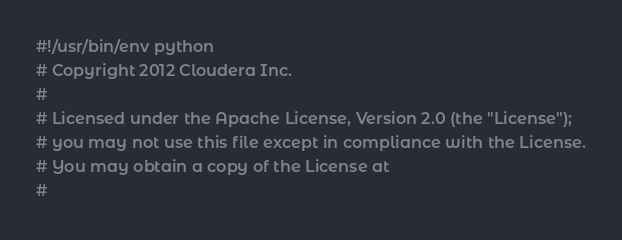<code> <loc_0><loc_0><loc_500><loc_500><_Python_>#!/usr/bin/env python
# Copyright 2012 Cloudera Inc.
#
# Licensed under the Apache License, Version 2.0 (the "License");
# you may not use this file except in compliance with the License.
# You may obtain a copy of the License at
#</code> 